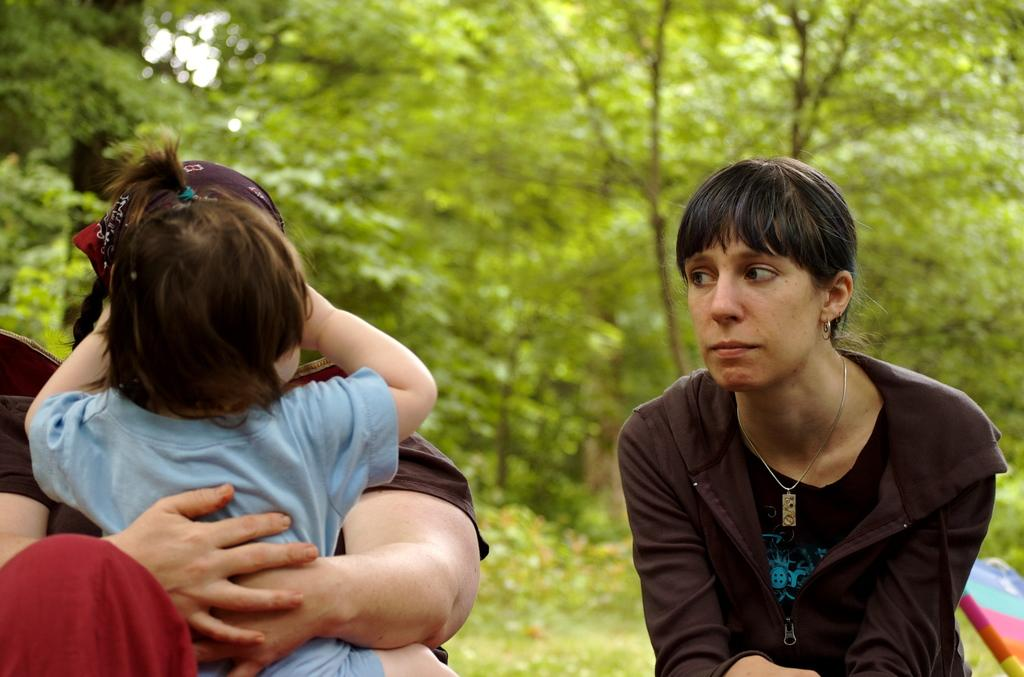What is the person in the image doing? The person is sitting on a chair in the image. What is the person holding in their arms? The person is holding a baby in their arms. Can you describe the woman in the image? There is a woman wearing a jacket in the image. What can be seen in the background of the image? There are trees and plants in the background of the image. What type of brake can be seen on the baby's stroller in the image? There is no stroller or brake present in the image; the person is holding the baby in their arms. 